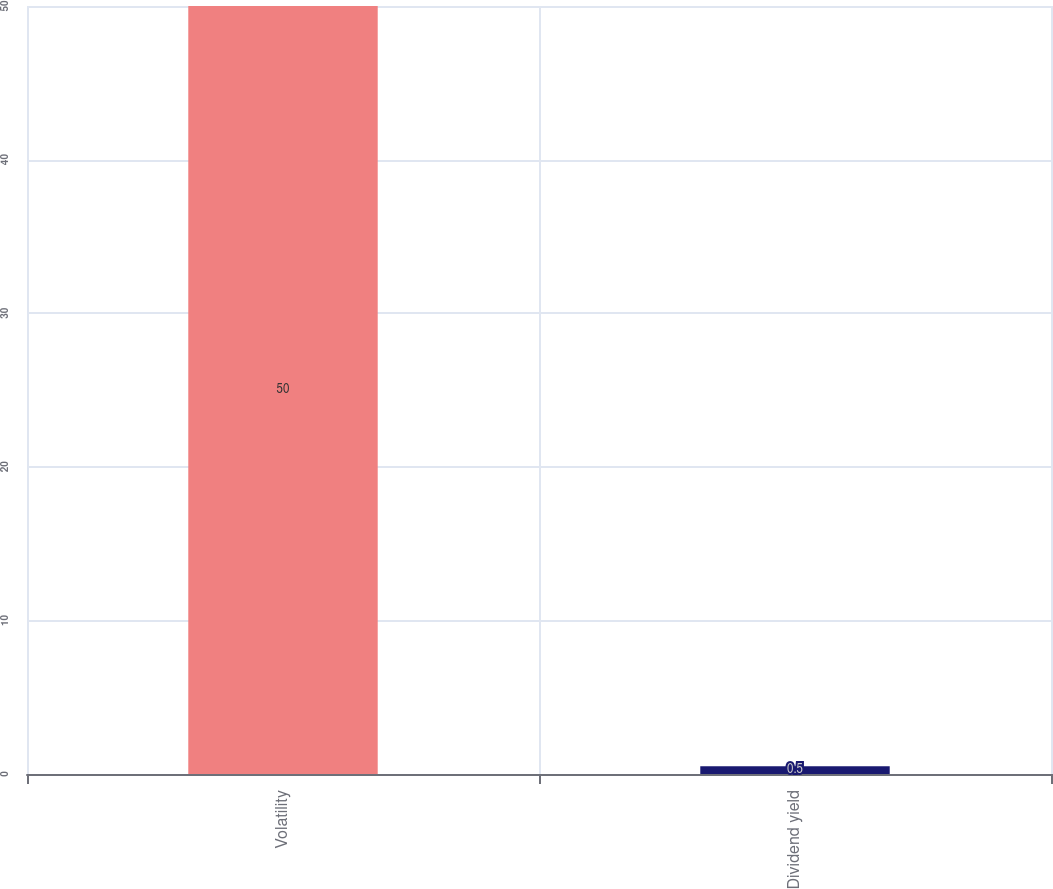Convert chart. <chart><loc_0><loc_0><loc_500><loc_500><bar_chart><fcel>Volatility<fcel>Dividend yield<nl><fcel>50<fcel>0.5<nl></chart> 